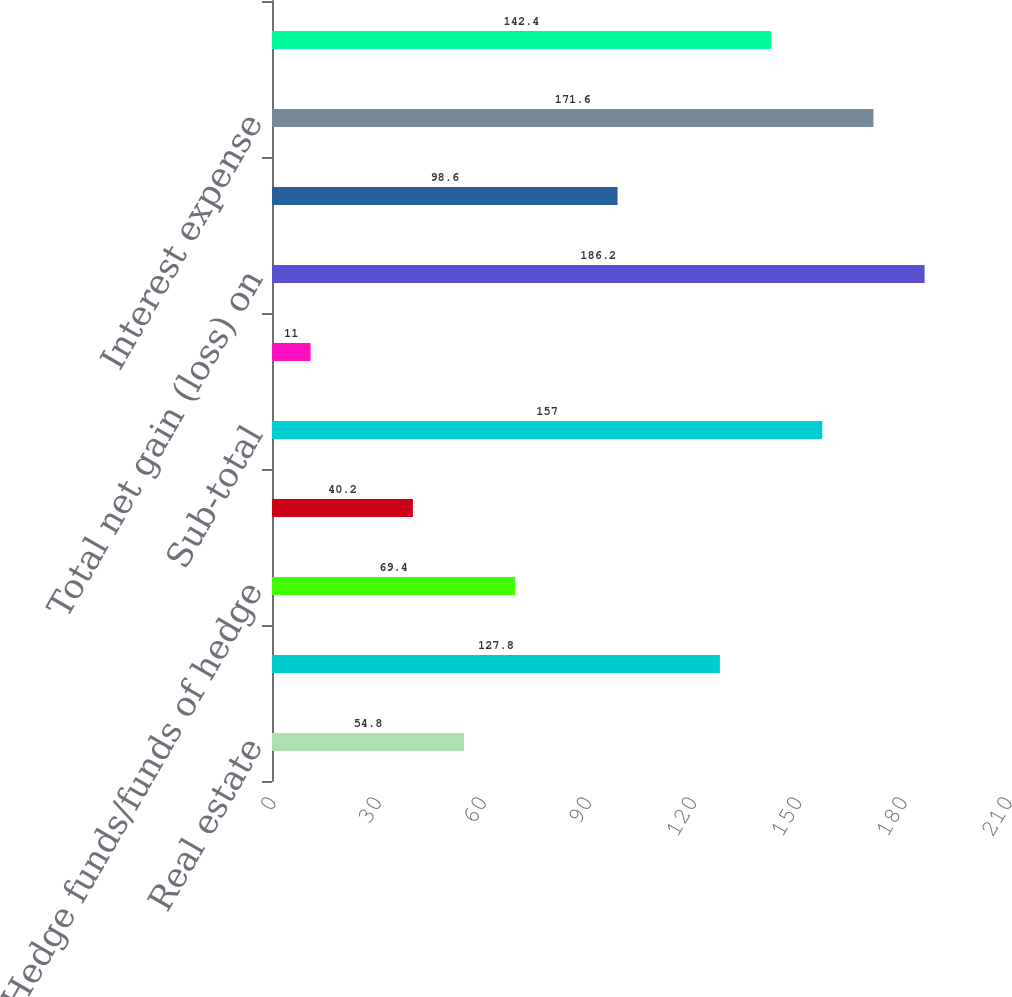<chart> <loc_0><loc_0><loc_500><loc_500><bar_chart><fcel>Real estate<fcel>Distressed credit/mortgage<fcel>Hedge funds/funds of hedge<fcel>Other investments (2)<fcel>Sub-total<fcel>Investments related to<fcel>Total net gain (loss) on<fcel>Interest and dividend income<fcel>Interest expense<fcel>Net interest expense<nl><fcel>54.8<fcel>127.8<fcel>69.4<fcel>40.2<fcel>157<fcel>11<fcel>186.2<fcel>98.6<fcel>171.6<fcel>142.4<nl></chart> 